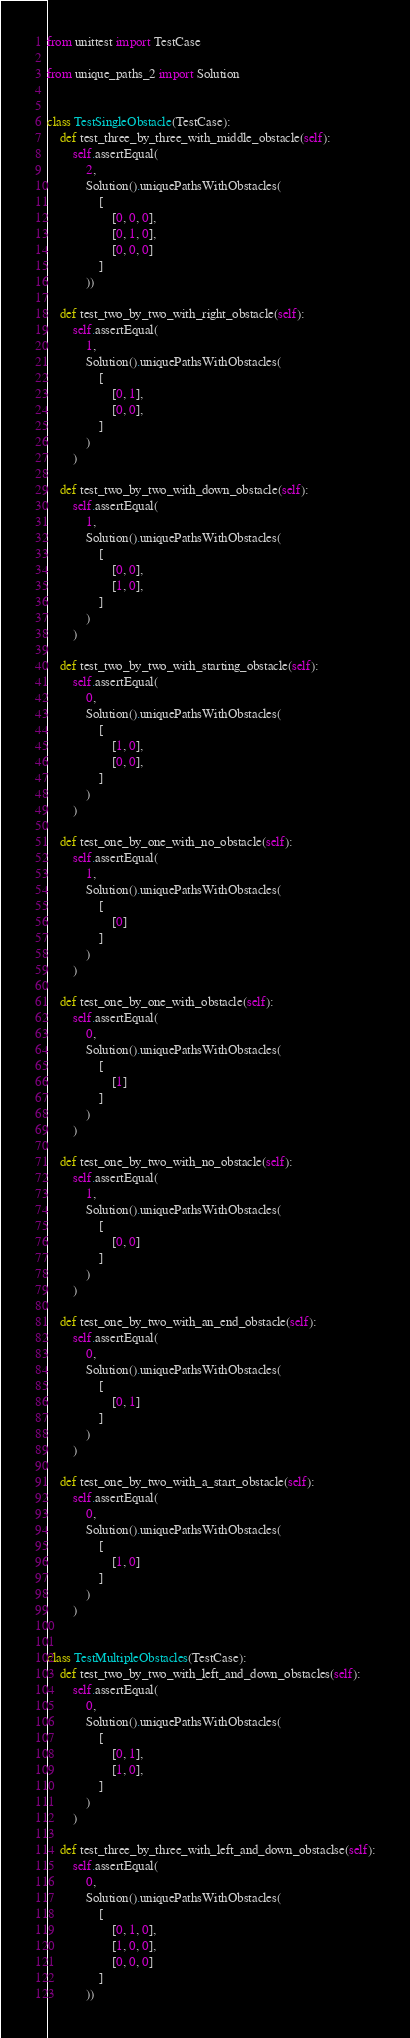Convert code to text. <code><loc_0><loc_0><loc_500><loc_500><_Python_>from unittest import TestCase

from unique_paths_2 import Solution


class TestSingleObstacle(TestCase):
    def test_three_by_three_with_middle_obstacle(self):
        self.assertEqual(
            2,
            Solution().uniquePathsWithObstacles(
                [
                    [0, 0, 0],
                    [0, 1, 0],
                    [0, 0, 0]
                ]
            ))

    def test_two_by_two_with_right_obstacle(self):
        self.assertEqual(
            1,
            Solution().uniquePathsWithObstacles(
                [
                    [0, 1],
                    [0, 0],
                ]
            )
        )

    def test_two_by_two_with_down_obstacle(self):
        self.assertEqual(
            1,
            Solution().uniquePathsWithObstacles(
                [
                    [0, 0],
                    [1, 0],
                ]
            )
        )

    def test_two_by_two_with_starting_obstacle(self):
        self.assertEqual(
            0,
            Solution().uniquePathsWithObstacles(
                [
                    [1, 0],
                    [0, 0],
                ]
            )
        )

    def test_one_by_one_with_no_obstacle(self):
        self.assertEqual(
            1,
            Solution().uniquePathsWithObstacles(
                [
                    [0]
                ]
            )
        )

    def test_one_by_one_with_obstacle(self):
        self.assertEqual(
            0,
            Solution().uniquePathsWithObstacles(
                [
                    [1]
                ]
            )
        )

    def test_one_by_two_with_no_obstacle(self):
        self.assertEqual(
            1,
            Solution().uniquePathsWithObstacles(
                [
                    [0, 0]
                ]
            )
        )

    def test_one_by_two_with_an_end_obstacle(self):
        self.assertEqual(
            0,
            Solution().uniquePathsWithObstacles(
                [
                    [0, 1]
                ]
            )
        )

    def test_one_by_two_with_a_start_obstacle(self):
        self.assertEqual(
            0,
            Solution().uniquePathsWithObstacles(
                [
                    [1, 0]
                ]
            )
        )


class TestMultipleObstacles(TestCase):
    def test_two_by_two_with_left_and_down_obstacles(self):
        self.assertEqual(
            0,
            Solution().uniquePathsWithObstacles(
                [
                    [0, 1],
                    [1, 0],
                ]
            )
        )

    def test_three_by_three_with_left_and_down_obstaclse(self):
        self.assertEqual(
            0,
            Solution().uniquePathsWithObstacles(
                [
                    [0, 1, 0],
                    [1, 0, 0],
                    [0, 0, 0]
                ]
            ))
</code> 